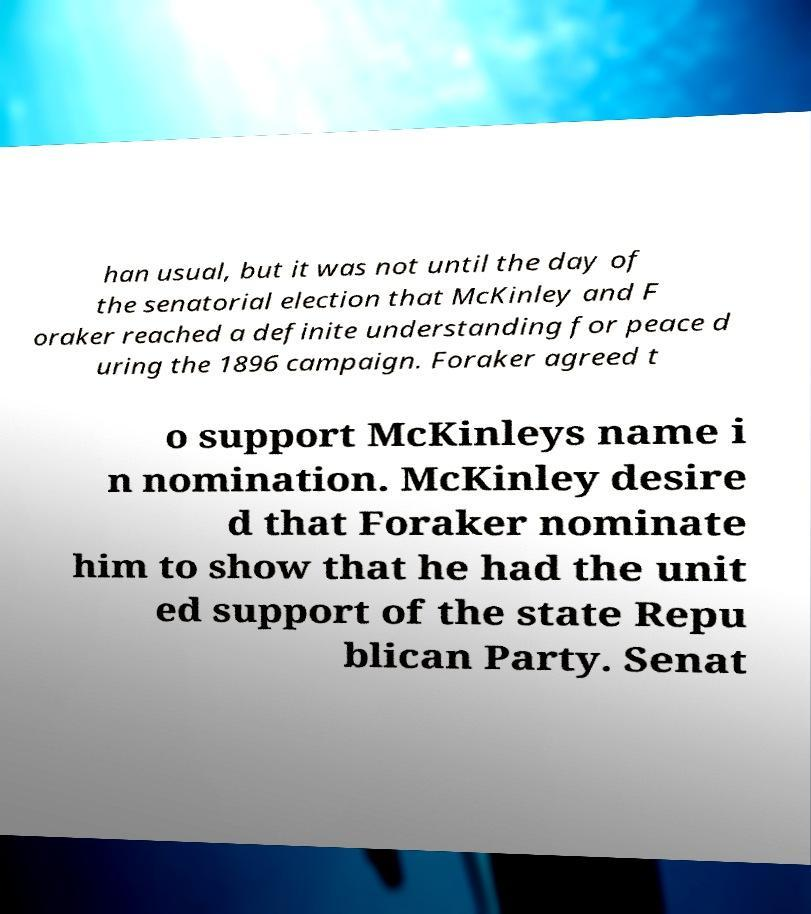I need the written content from this picture converted into text. Can you do that? han usual, but it was not until the day of the senatorial election that McKinley and F oraker reached a definite understanding for peace d uring the 1896 campaign. Foraker agreed t o support McKinleys name i n nomination. McKinley desire d that Foraker nominate him to show that he had the unit ed support of the state Repu blican Party. Senat 